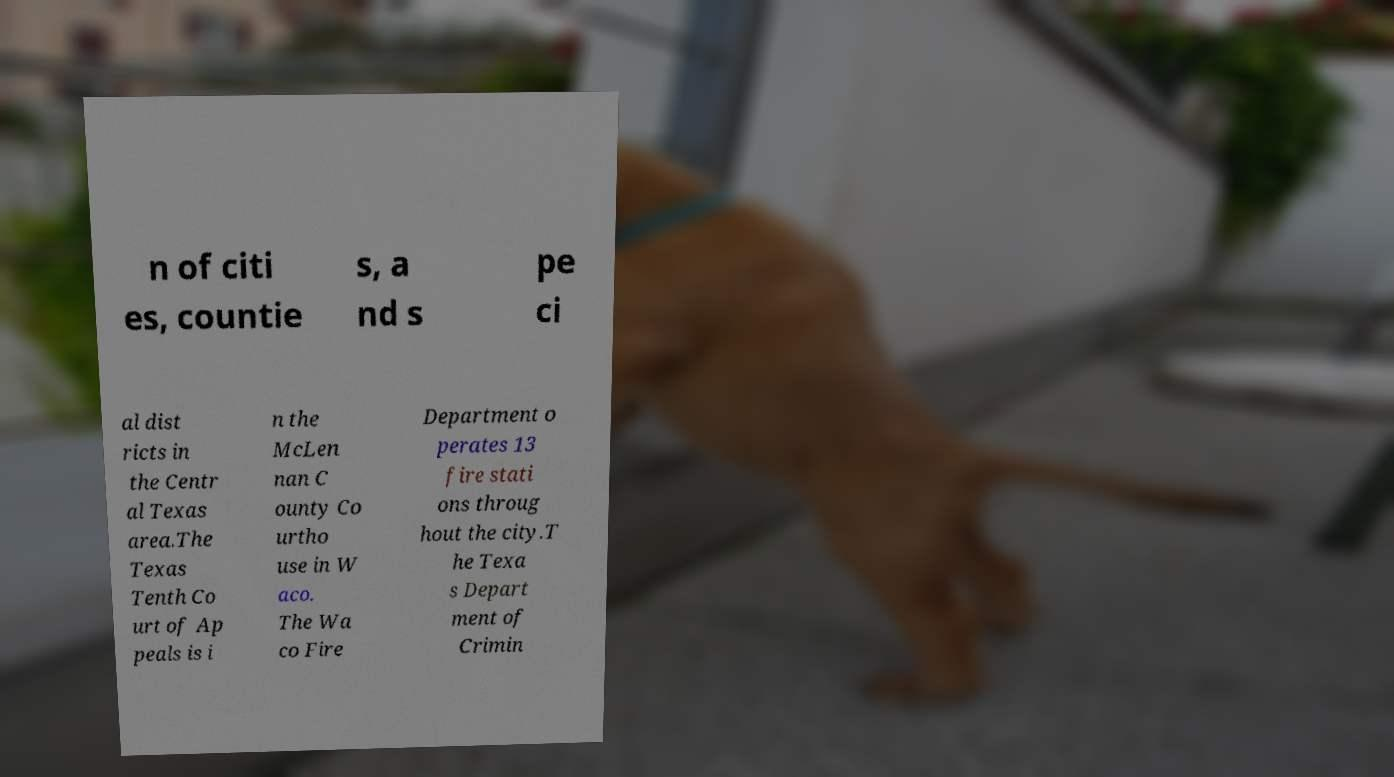I need the written content from this picture converted into text. Can you do that? n of citi es, countie s, a nd s pe ci al dist ricts in the Centr al Texas area.The Texas Tenth Co urt of Ap peals is i n the McLen nan C ounty Co urtho use in W aco. The Wa co Fire Department o perates 13 fire stati ons throug hout the city.T he Texa s Depart ment of Crimin 